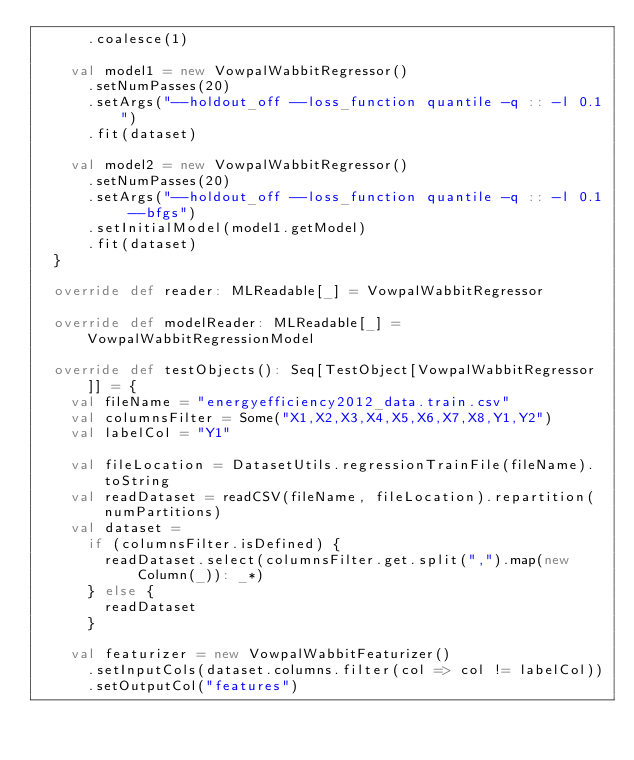Convert code to text. <code><loc_0><loc_0><loc_500><loc_500><_Scala_>      .coalesce(1)

    val model1 = new VowpalWabbitRegressor()
      .setNumPasses(20)
      .setArgs("--holdout_off --loss_function quantile -q :: -l 0.1")
      .fit(dataset)

    val model2 = new VowpalWabbitRegressor()
      .setNumPasses(20)
      .setArgs("--holdout_off --loss_function quantile -q :: -l 0.1 --bfgs")
      .setInitialModel(model1.getModel)
      .fit(dataset)
  }

  override def reader: MLReadable[_] = VowpalWabbitRegressor

  override def modelReader: MLReadable[_] = VowpalWabbitRegressionModel

  override def testObjects(): Seq[TestObject[VowpalWabbitRegressor]] = {
    val fileName = "energyefficiency2012_data.train.csv"
    val columnsFilter = Some("X1,X2,X3,X4,X5,X6,X7,X8,Y1,Y2")
    val labelCol = "Y1"

    val fileLocation = DatasetUtils.regressionTrainFile(fileName).toString
    val readDataset = readCSV(fileName, fileLocation).repartition(numPartitions)
    val dataset =
      if (columnsFilter.isDefined) {
        readDataset.select(columnsFilter.get.split(",").map(new Column(_)): _*)
      } else {
        readDataset
      }

    val featurizer = new VowpalWabbitFeaturizer()
      .setInputCols(dataset.columns.filter(col => col != labelCol))
      .setOutputCol("features")
</code> 